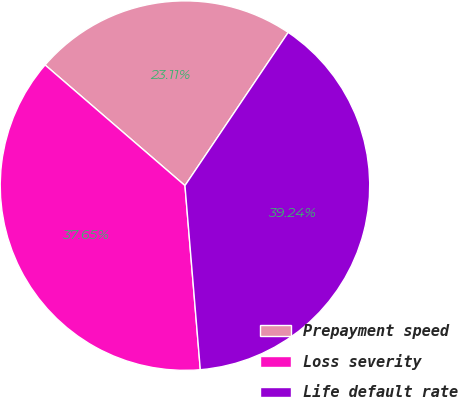<chart> <loc_0><loc_0><loc_500><loc_500><pie_chart><fcel>Prepayment speed<fcel>Loss severity<fcel>Life default rate<nl><fcel>23.11%<fcel>37.65%<fcel>39.24%<nl></chart> 